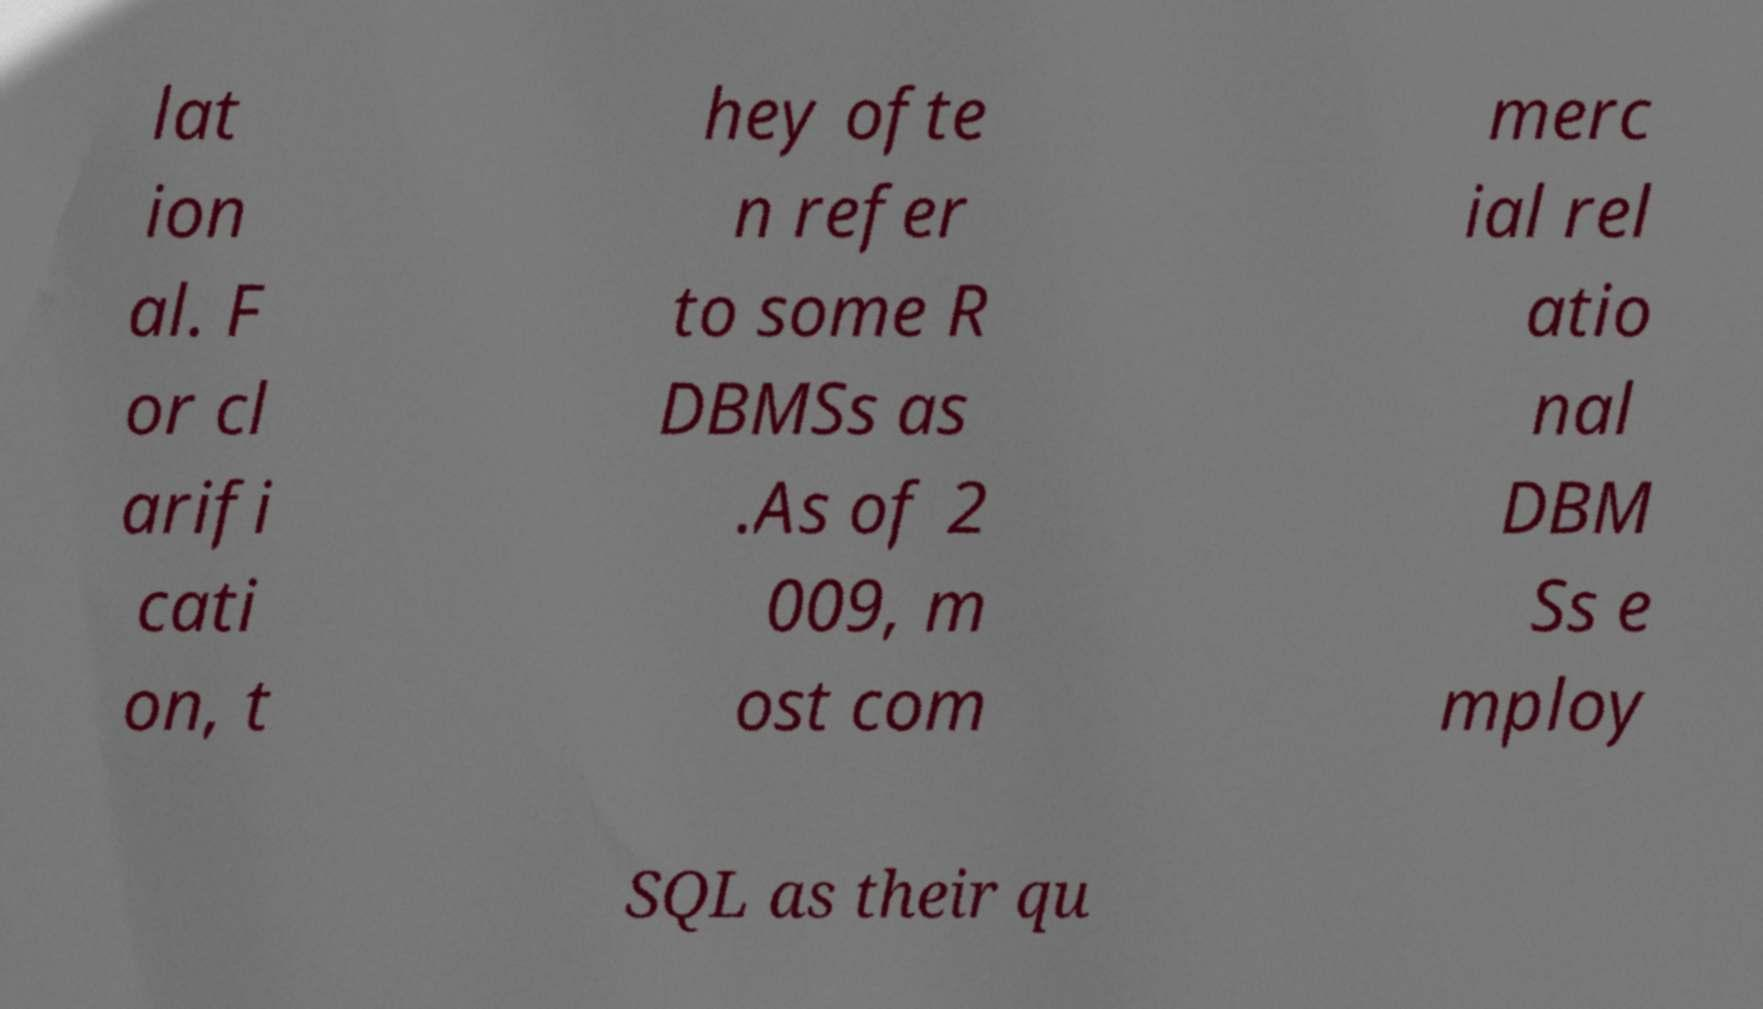Please identify and transcribe the text found in this image. lat ion al. F or cl arifi cati on, t hey ofte n refer to some R DBMSs as .As of 2 009, m ost com merc ial rel atio nal DBM Ss e mploy SQL as their qu 